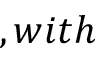<formula> <loc_0><loc_0><loc_500><loc_500>, w i t h</formula> 